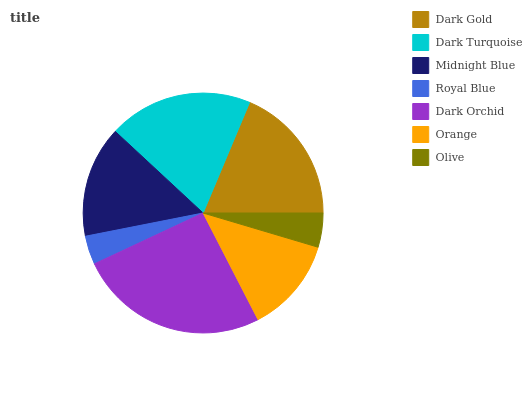Is Royal Blue the minimum?
Answer yes or no. Yes. Is Dark Orchid the maximum?
Answer yes or no. Yes. Is Dark Turquoise the minimum?
Answer yes or no. No. Is Dark Turquoise the maximum?
Answer yes or no. No. Is Dark Turquoise greater than Dark Gold?
Answer yes or no. Yes. Is Dark Gold less than Dark Turquoise?
Answer yes or no. Yes. Is Dark Gold greater than Dark Turquoise?
Answer yes or no. No. Is Dark Turquoise less than Dark Gold?
Answer yes or no. No. Is Midnight Blue the high median?
Answer yes or no. Yes. Is Midnight Blue the low median?
Answer yes or no. Yes. Is Royal Blue the high median?
Answer yes or no. No. Is Olive the low median?
Answer yes or no. No. 